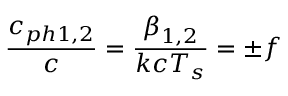<formula> <loc_0><loc_0><loc_500><loc_500>\frac { c _ { p h 1 , 2 } } { c } = \frac { \beta _ { 1 , 2 } } { k c T _ { s } } = \pm f</formula> 